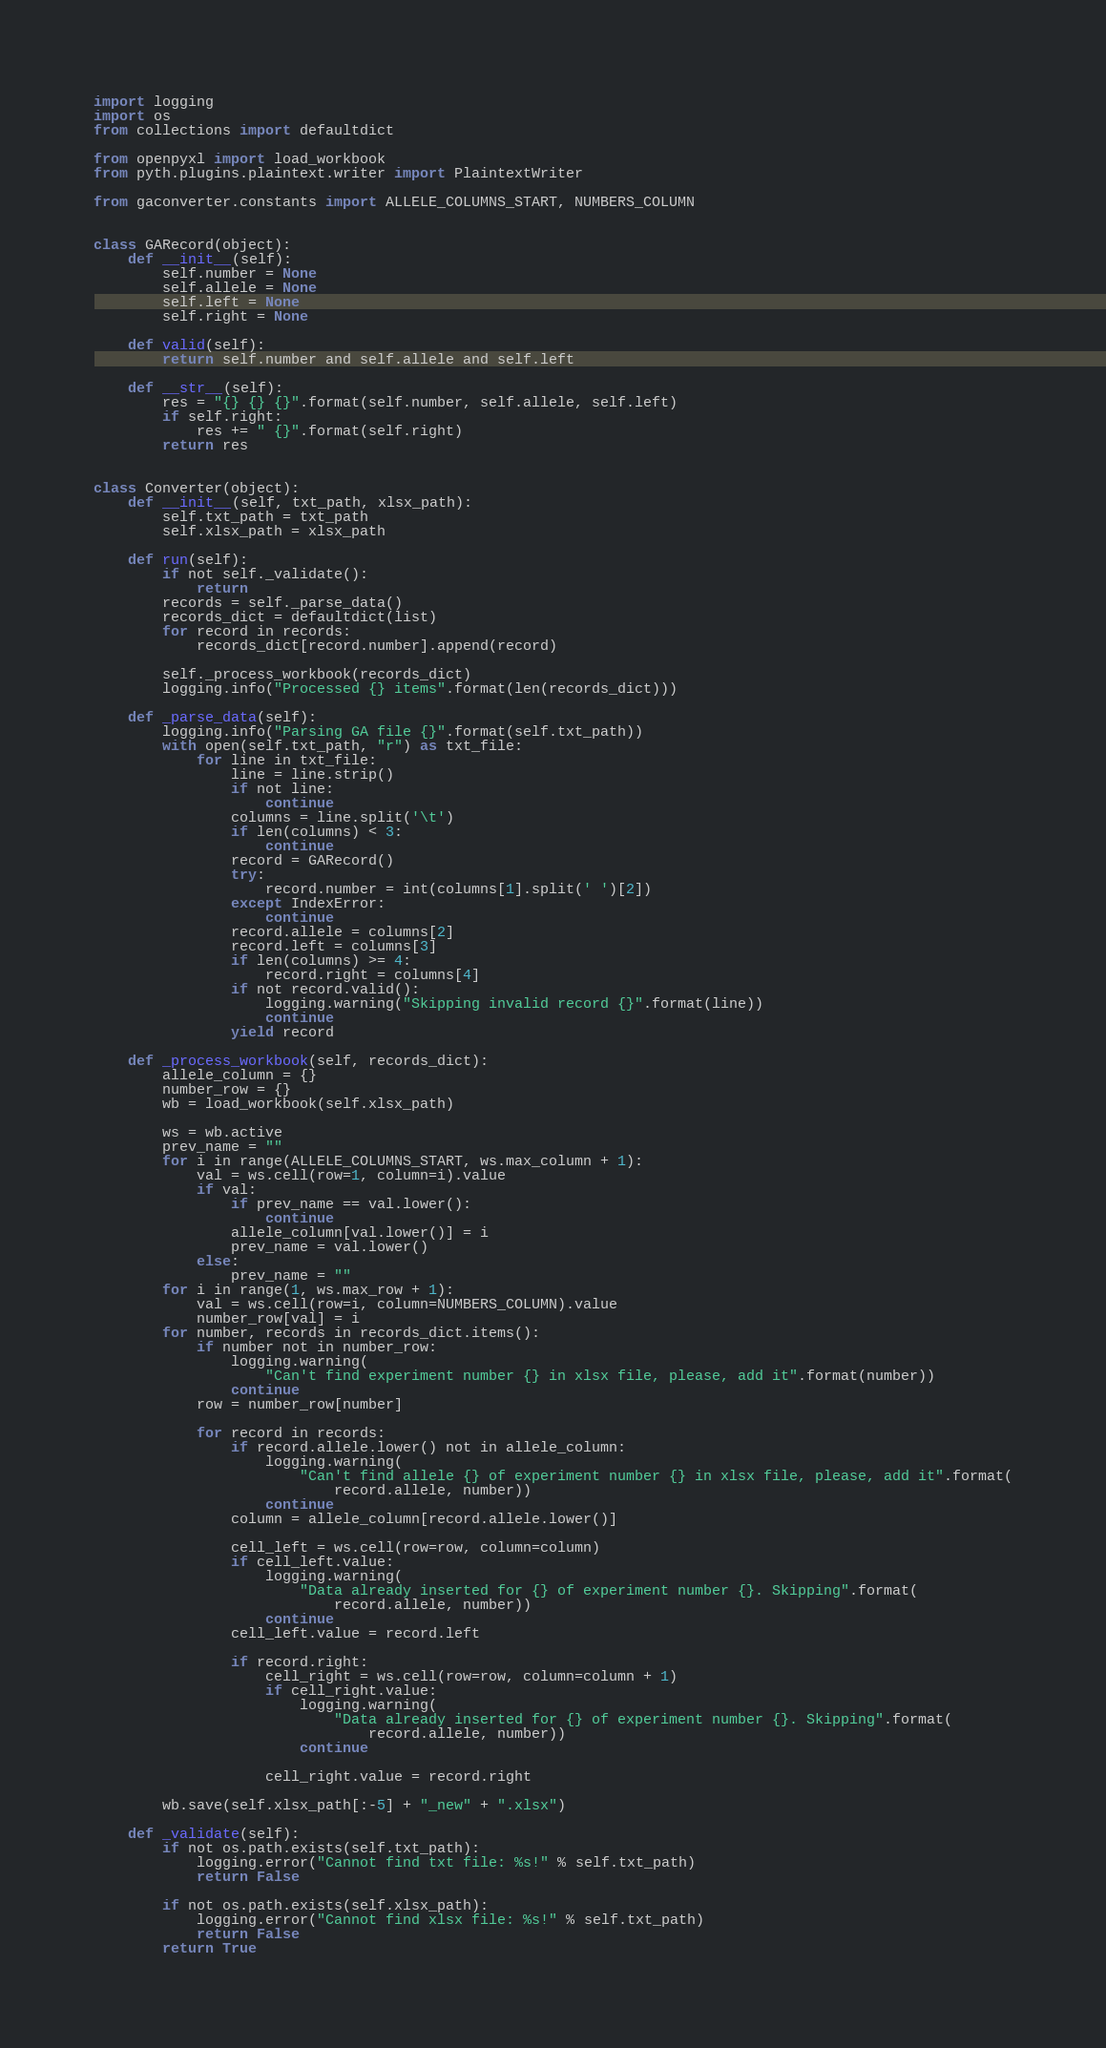Convert code to text. <code><loc_0><loc_0><loc_500><loc_500><_Python_>import logging
import os
from collections import defaultdict

from openpyxl import load_workbook
from pyth.plugins.plaintext.writer import PlaintextWriter

from gaconverter.constants import ALLELE_COLUMNS_START, NUMBERS_COLUMN


class GARecord(object):
    def __init__(self):
        self.number = None
        self.allele = None
        self.left = None
        self.right = None

    def valid(self):
        return self.number and self.allele and self.left

    def __str__(self):
        res = "{} {} {}".format(self.number, self.allele, self.left)
        if self.right:
            res += " {}".format(self.right)
        return res


class Converter(object):
    def __init__(self, txt_path, xlsx_path):
        self.txt_path = txt_path
        self.xlsx_path = xlsx_path

    def run(self):
        if not self._validate():
            return
        records = self._parse_data()
        records_dict = defaultdict(list)
        for record in records:
            records_dict[record.number].append(record)

        self._process_workbook(records_dict)
        logging.info("Processed {} items".format(len(records_dict)))

    def _parse_data(self):
        logging.info("Parsing GA file {}".format(self.txt_path))
        with open(self.txt_path, "r") as txt_file:
            for line in txt_file:
                line = line.strip()
                if not line:
                    continue
                columns = line.split('\t')
                if len(columns) < 3:
                    continue
                record = GARecord()
                try:
                    record.number = int(columns[1].split(' ')[2])
                except IndexError:
                    continue
                record.allele = columns[2]
                record.left = columns[3]
                if len(columns) >= 4:
                    record.right = columns[4]
                if not record.valid():
                    logging.warning("Skipping invalid record {}".format(line))
                    continue
                yield record

    def _process_workbook(self, records_dict):
        allele_column = {}
        number_row = {}
        wb = load_workbook(self.xlsx_path)

        ws = wb.active
        prev_name = ""
        for i in range(ALLELE_COLUMNS_START, ws.max_column + 1):
            val = ws.cell(row=1, column=i).value
            if val:
                if prev_name == val.lower():
                    continue
                allele_column[val.lower()] = i
                prev_name = val.lower()
            else:
                prev_name = ""
        for i in range(1, ws.max_row + 1):
            val = ws.cell(row=i, column=NUMBERS_COLUMN).value
            number_row[val] = i
        for number, records in records_dict.items():
            if number not in number_row:
                logging.warning(
                    "Can't find experiment number {} in xlsx file, please, add it".format(number))
                continue
            row = number_row[number]

            for record in records:
                if record.allele.lower() not in allele_column:
                    logging.warning(
                        "Can't find allele {} of experiment number {} in xlsx file, please, add it".format(
                            record.allele, number))
                    continue
                column = allele_column[record.allele.lower()]

                cell_left = ws.cell(row=row, column=column)
                if cell_left.value:
                    logging.warning(
                        "Data already inserted for {} of experiment number {}. Skipping".format(
                            record.allele, number))
                    continue
                cell_left.value = record.left

                if record.right:
                    cell_right = ws.cell(row=row, column=column + 1)
                    if cell_right.value:
                        logging.warning(
                            "Data already inserted for {} of experiment number {}. Skipping".format(
                                record.allele, number))
                        continue

                    cell_right.value = record.right

        wb.save(self.xlsx_path[:-5] + "_new" + ".xlsx")

    def _validate(self):
        if not os.path.exists(self.txt_path):
            logging.error("Cannot find txt file: %s!" % self.txt_path)
            return False

        if not os.path.exists(self.xlsx_path):
            logging.error("Cannot find xlsx file: %s!" % self.txt_path)
            return False
        return True
</code> 